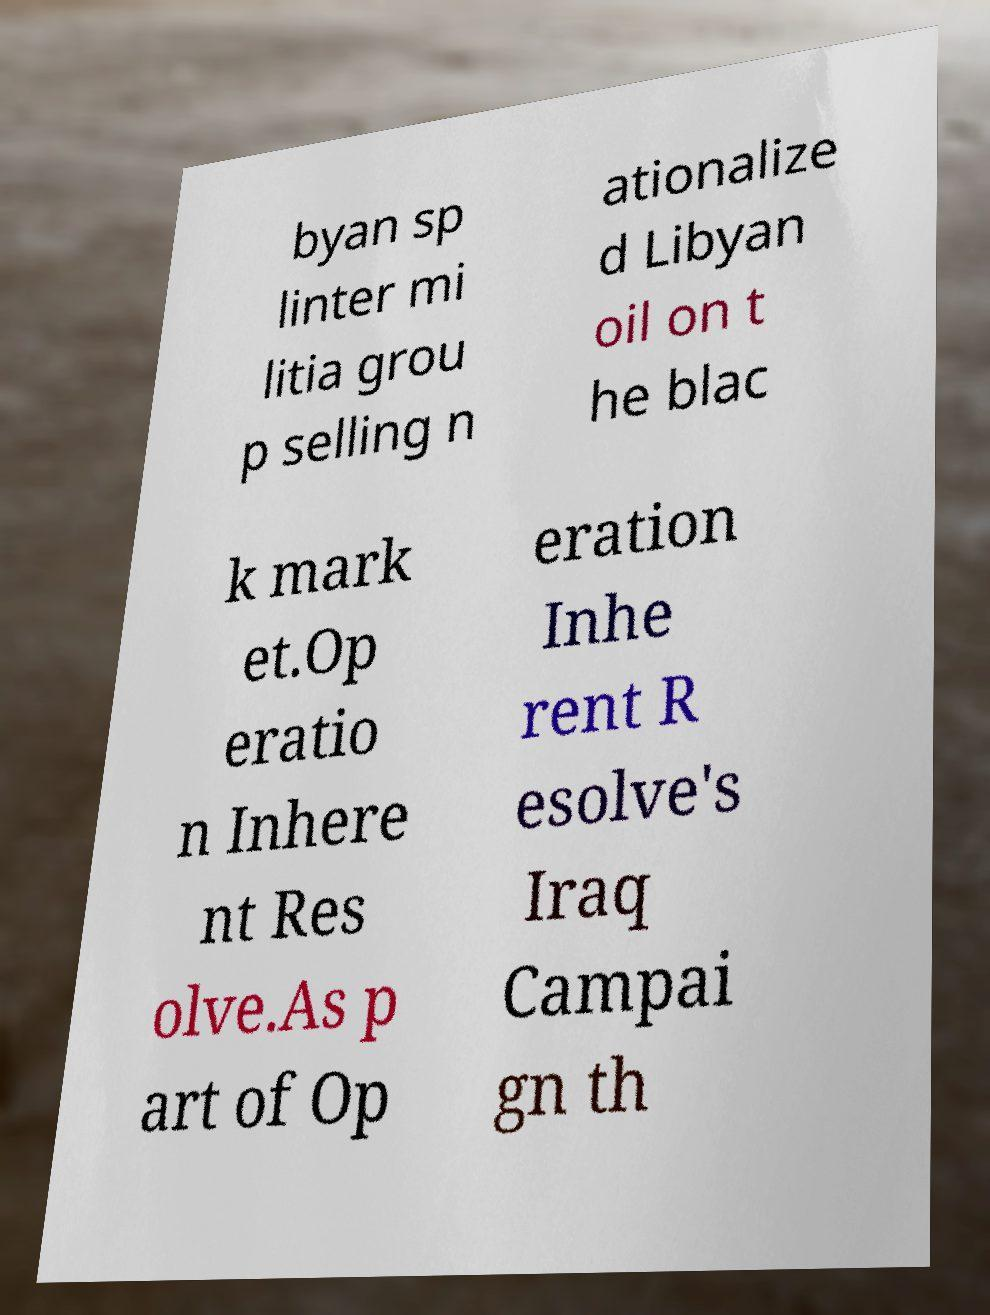I need the written content from this picture converted into text. Can you do that? byan sp linter mi litia grou p selling n ationalize d Libyan oil on t he blac k mark et.Op eratio n Inhere nt Res olve.As p art of Op eration Inhe rent R esolve's Iraq Campai gn th 